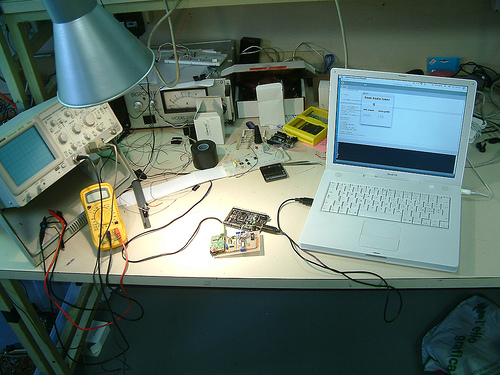<image>
Is there a laptop to the right of the table? No. The laptop is not to the right of the table. The horizontal positioning shows a different relationship. 